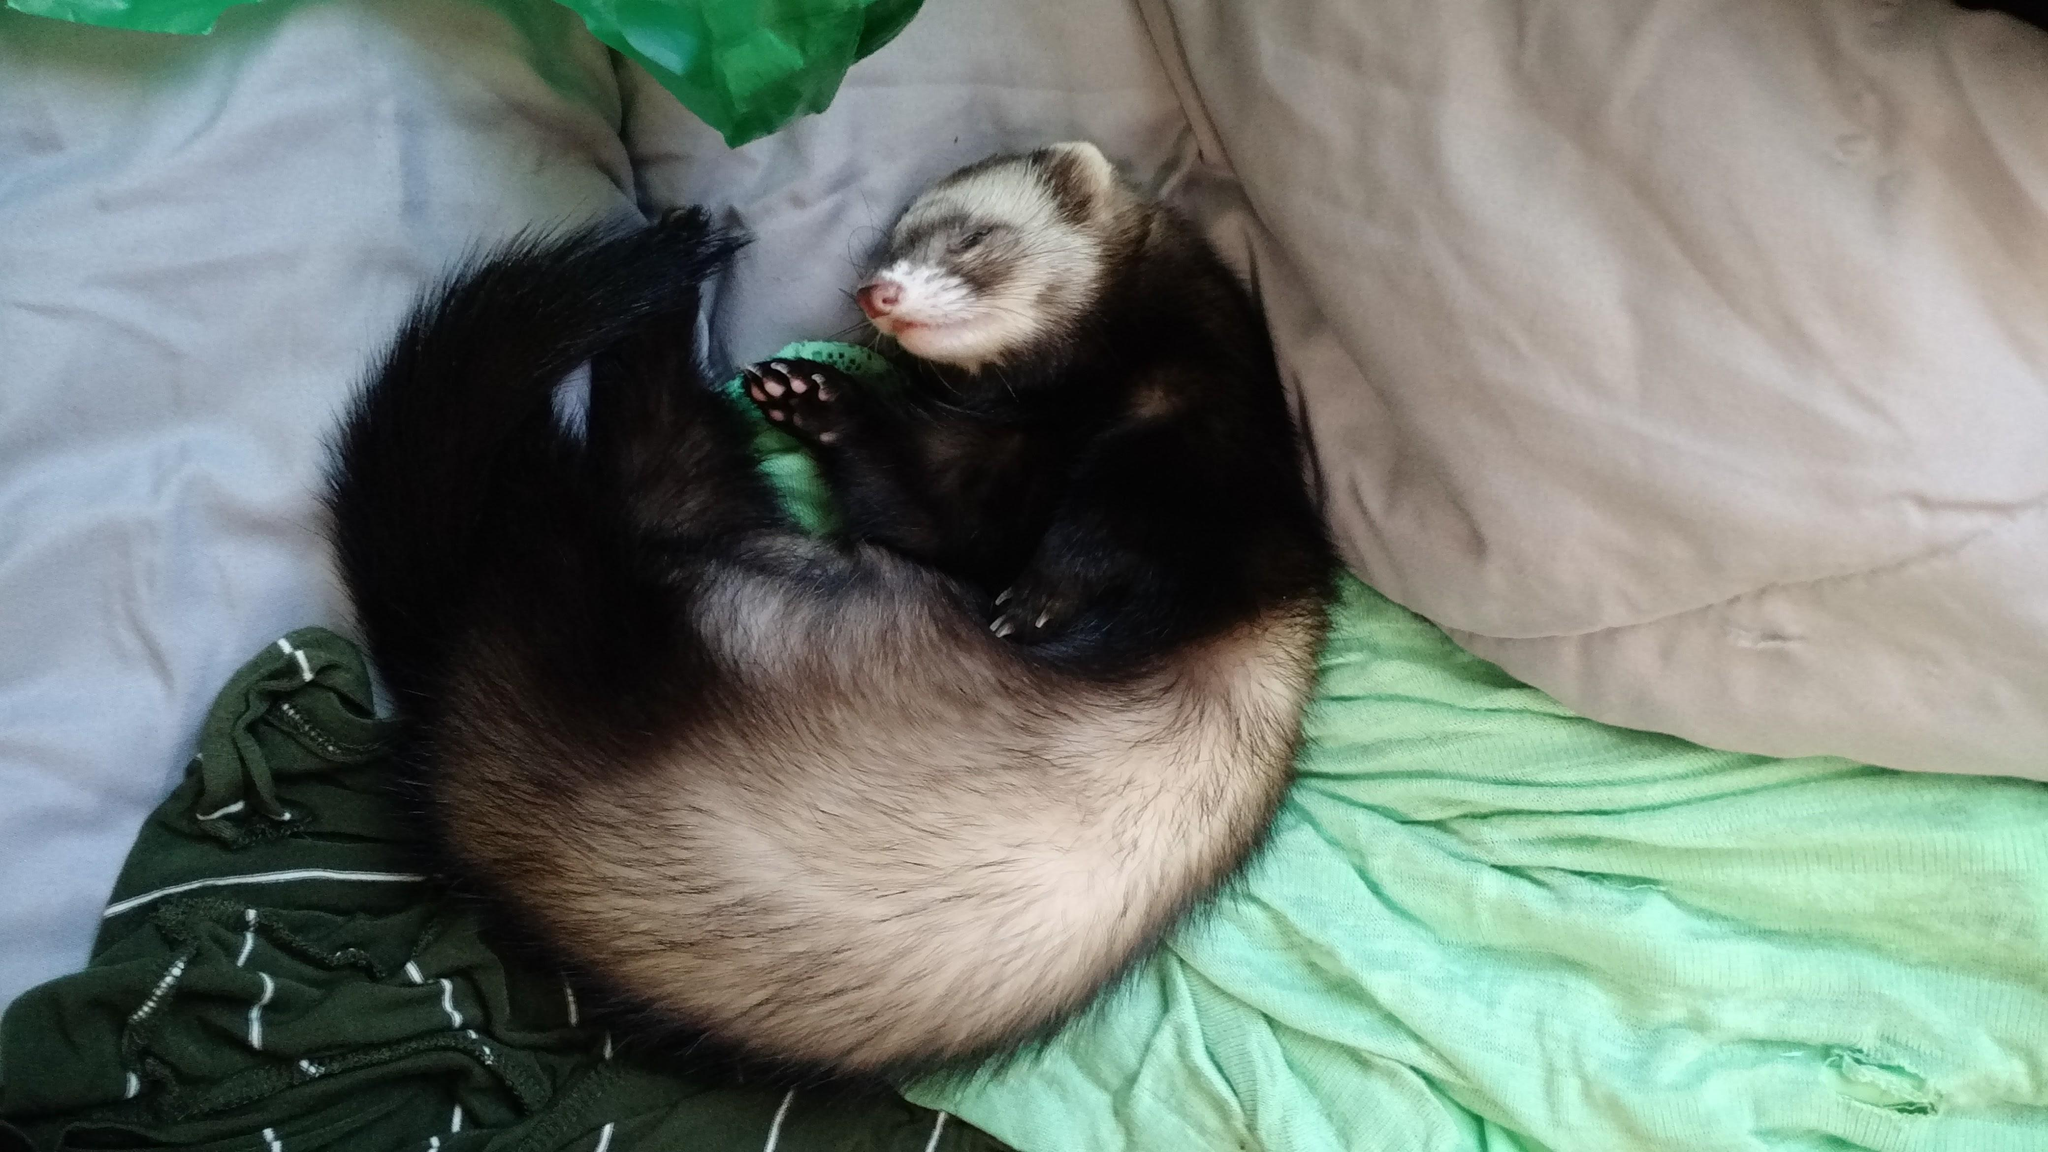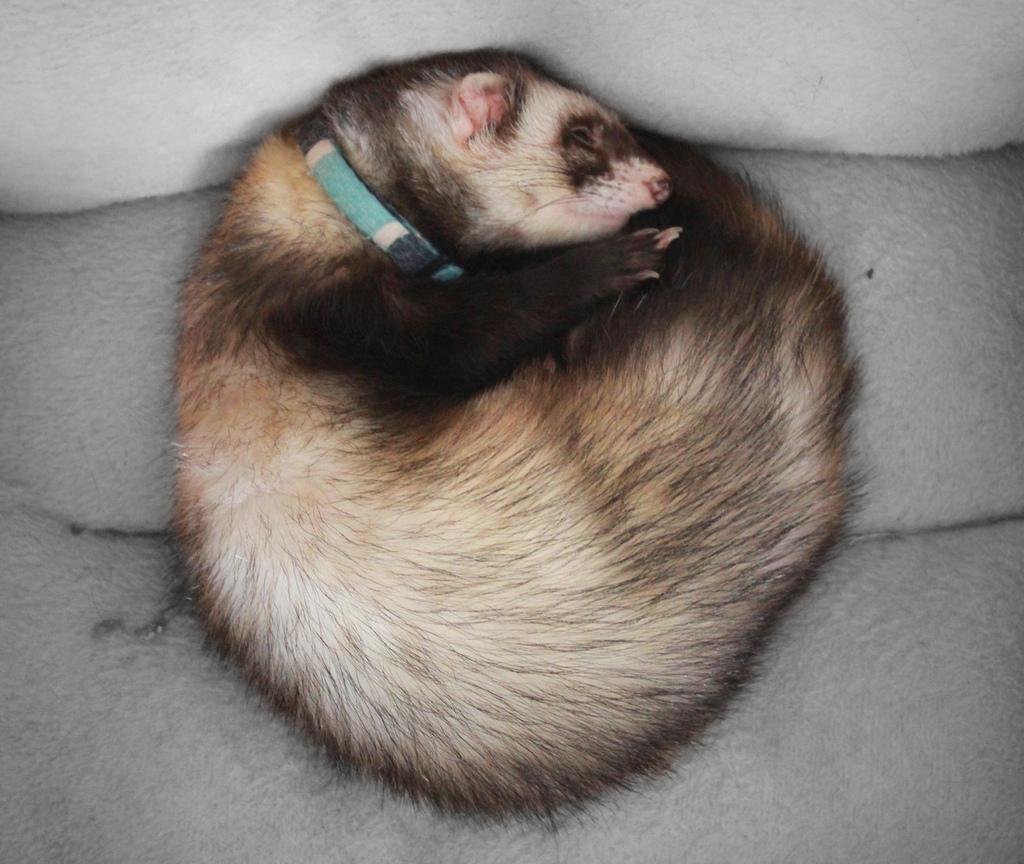The first image is the image on the left, the second image is the image on the right. For the images shown, is this caption "There are a total of three ferrets." true? Answer yes or no. No. 